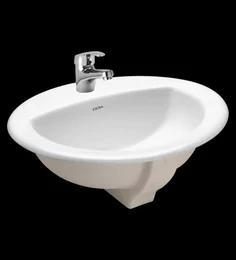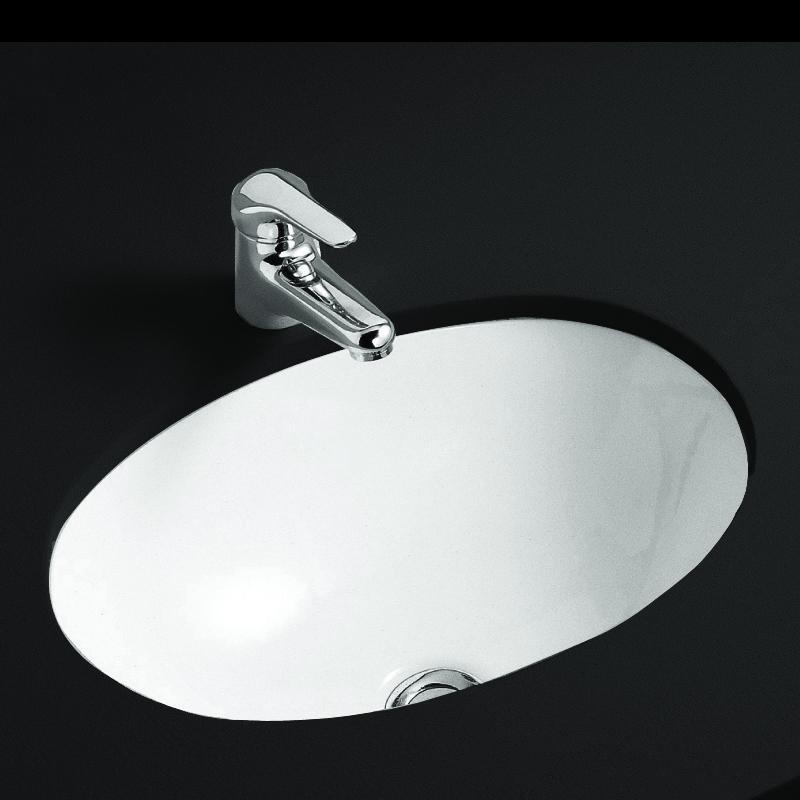The first image is the image on the left, the second image is the image on the right. Given the left and right images, does the statement "An image shows a sink with a semi-circle interior and chrome fixture mounted to the basin's top." hold true? Answer yes or no. Yes. The first image is the image on the left, the second image is the image on the right. Evaluate the accuracy of this statement regarding the images: "There are two oval shaped sinks installed in countertops.". Is it true? Answer yes or no. No. 